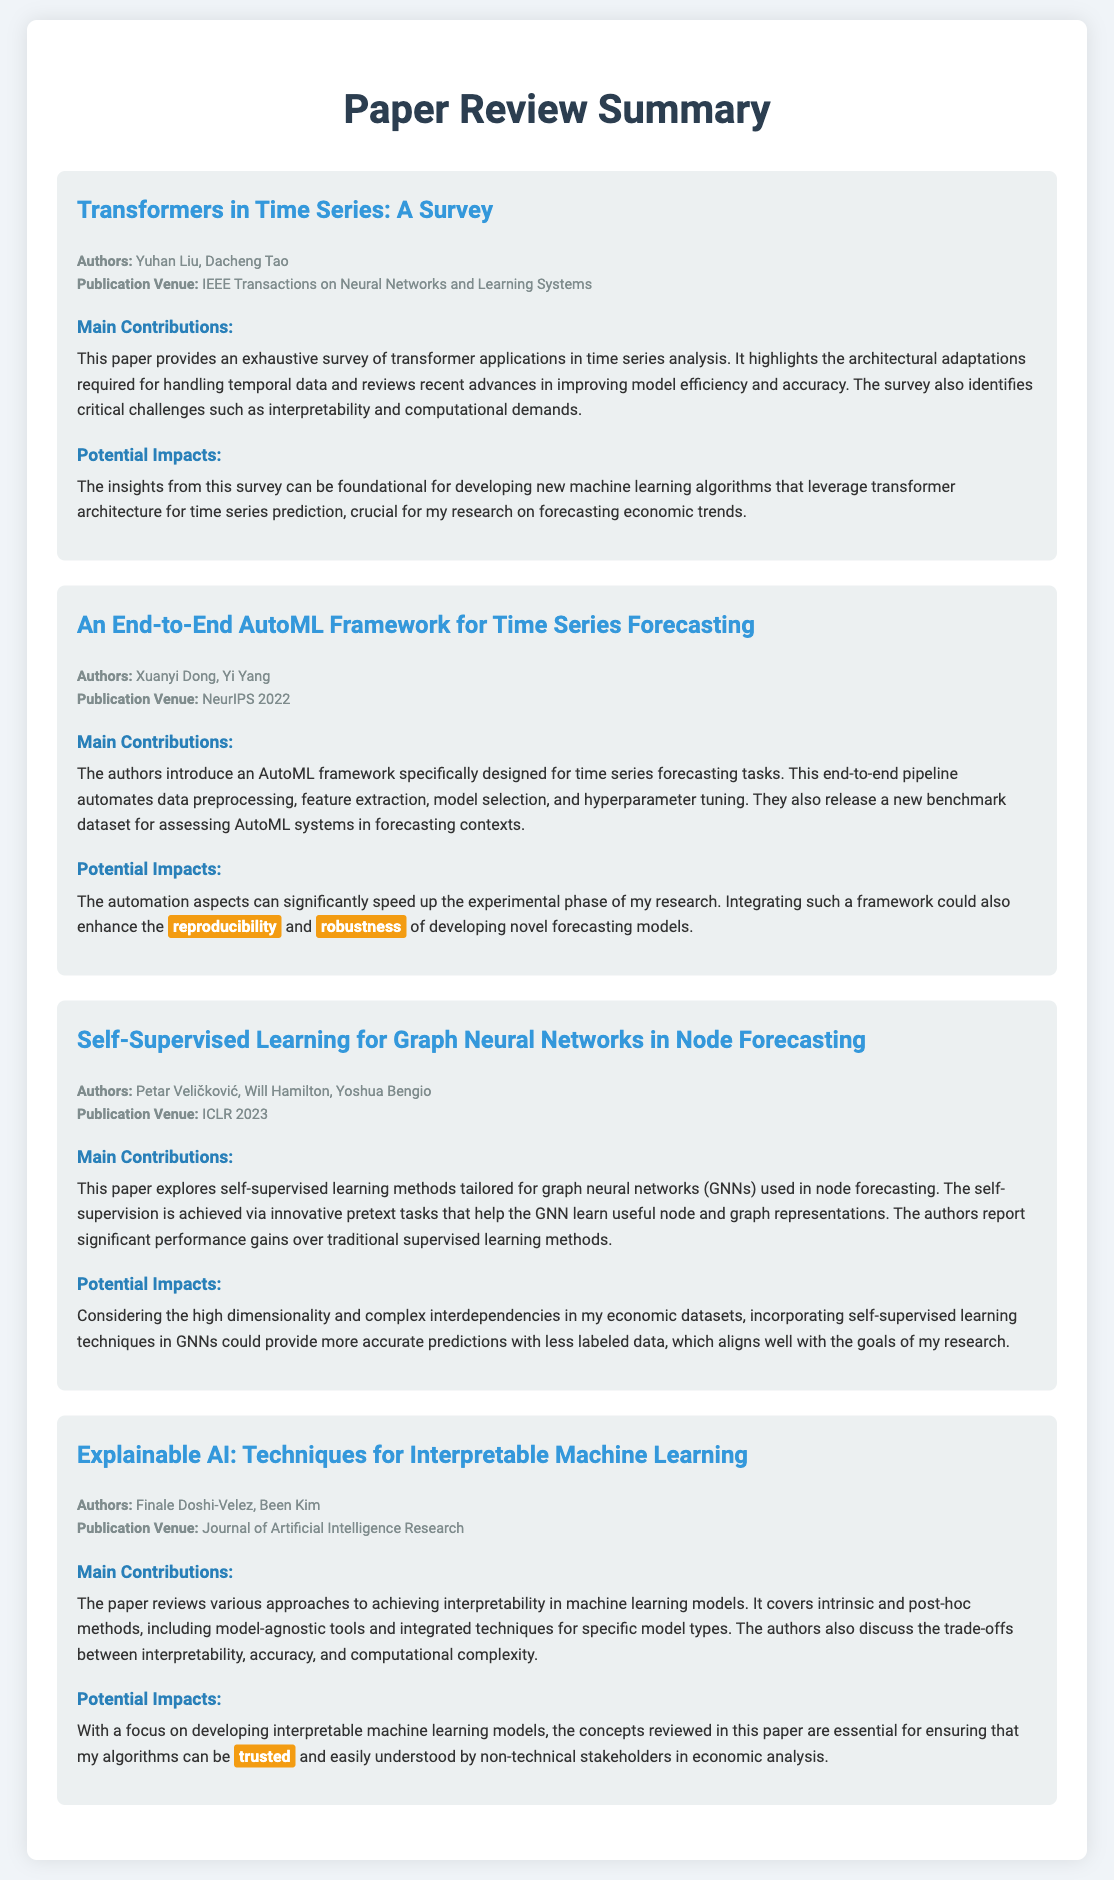What is the title of the first paper? The title of the first paper is provided in the document under the first paper section.
Answer: Transformers in Time Series: A Survey Who are the authors of the second paper? The authors of the second paper are mentioned in the paper's information section.
Answer: Xuanyi Dong, Yi Yang What is the publication venue of the paper on self-supervised learning? The publication venue for self-supervised learning is noted in the document's specific section for that paper.
Answer: ICLR 2023 What is a key challenge identified in the survey about transformers? The challenges are outlined in the main contributions section of the first paper.
Answer: Interpretability and computational demands How does the AutoML framework affect the experimental phase of research? The document explains the impact of the AutoML framework on research in its potential impacts section.
Answer: Speed up the experimental phase What type of techniques does the paper on explainable AI review? The techniques covered in the explainable AI paper are listed in the main contributions section.
Answer: Interpretability techniques How does self-supervised learning benefit node forecasting? The benefit is described under potential impacts in the self-supervised learning paper.
Answer: More accurate predictions with less labeled data What underlying theme connects all the papers summarized? The overall theme can be inferred by examining the contributions and potential impacts of each paper in relation to machine learning advancement.
Answer: Innovative machine learning approaches 